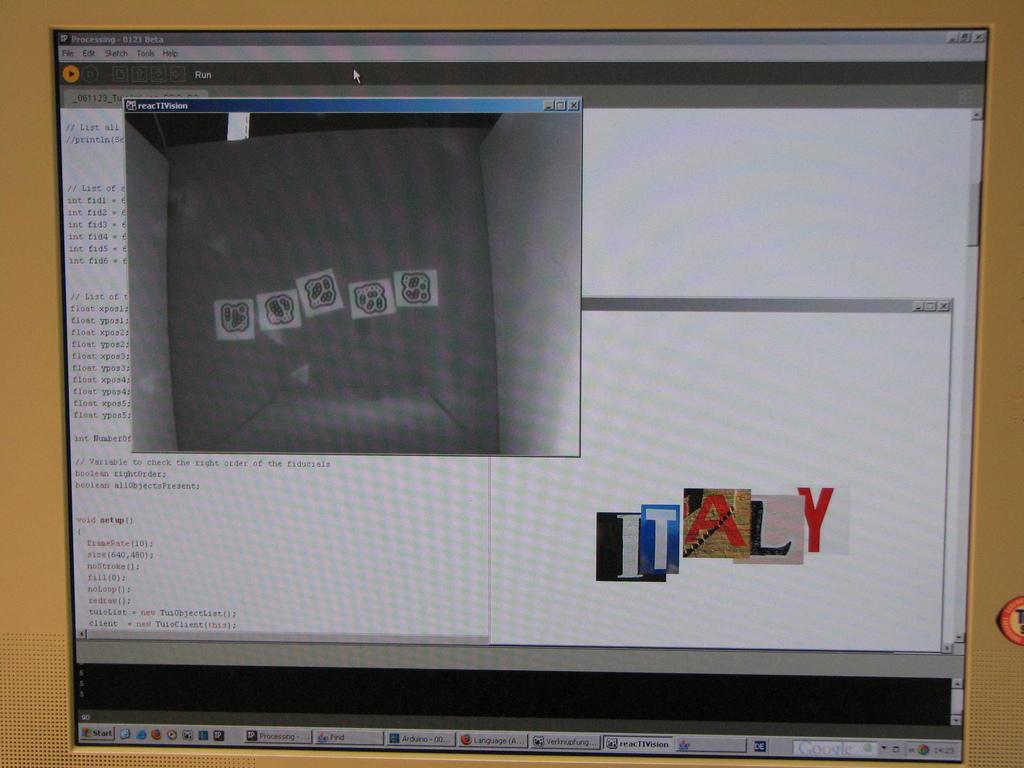Provide a one-sentence caption for the provided image. a computer screen with the word Italy on it in the bottom right. 